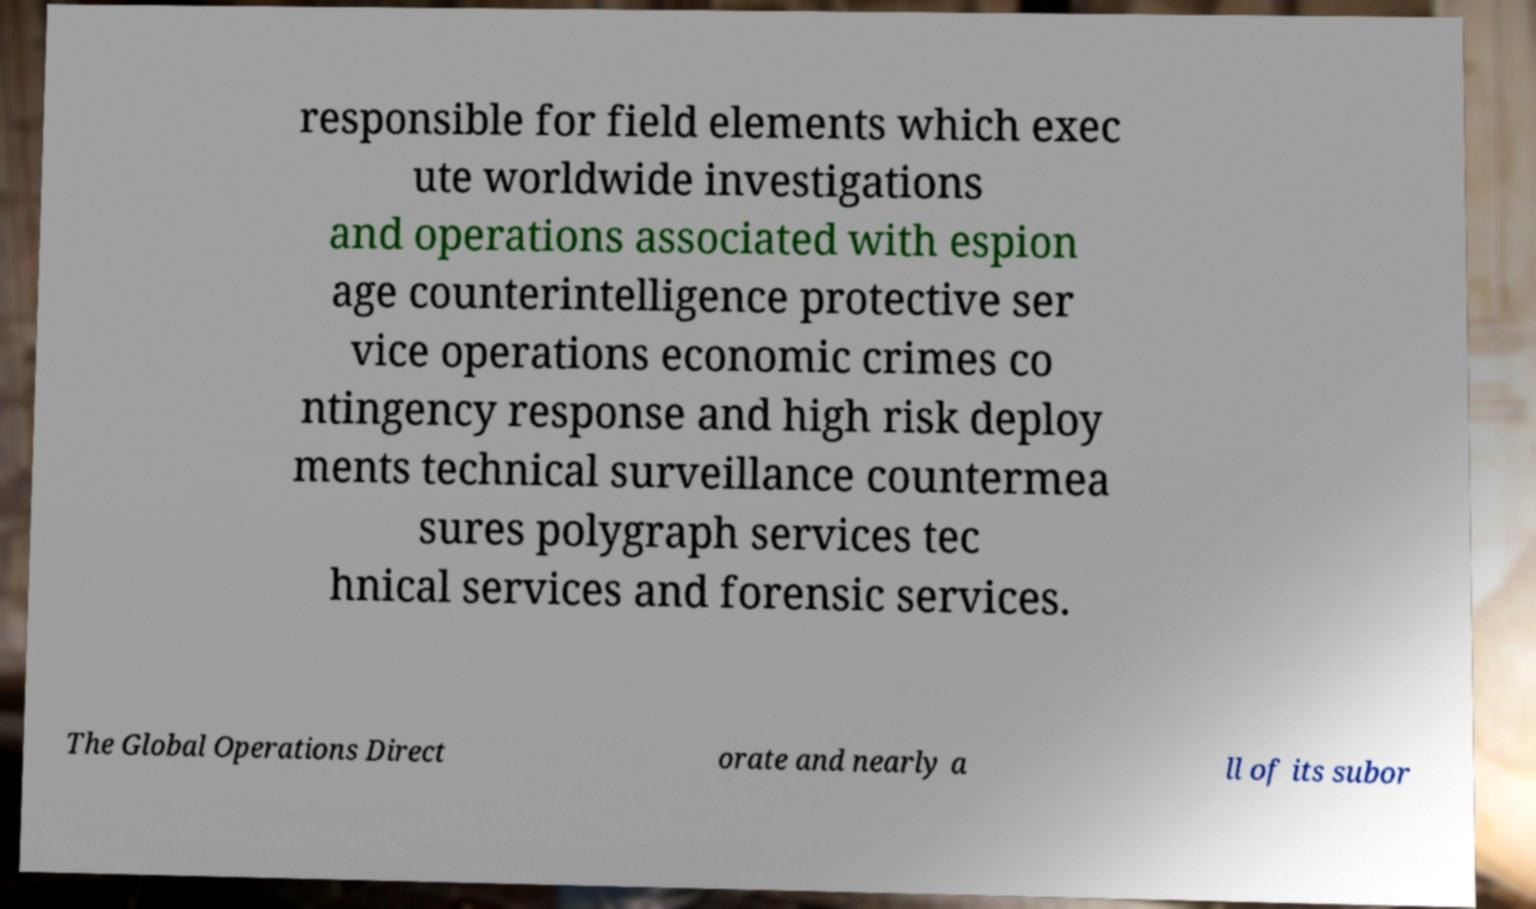For documentation purposes, I need the text within this image transcribed. Could you provide that? responsible for field elements which exec ute worldwide investigations and operations associated with espion age counterintelligence protective ser vice operations economic crimes co ntingency response and high risk deploy ments technical surveillance countermea sures polygraph services tec hnical services and forensic services. The Global Operations Direct orate and nearly a ll of its subor 